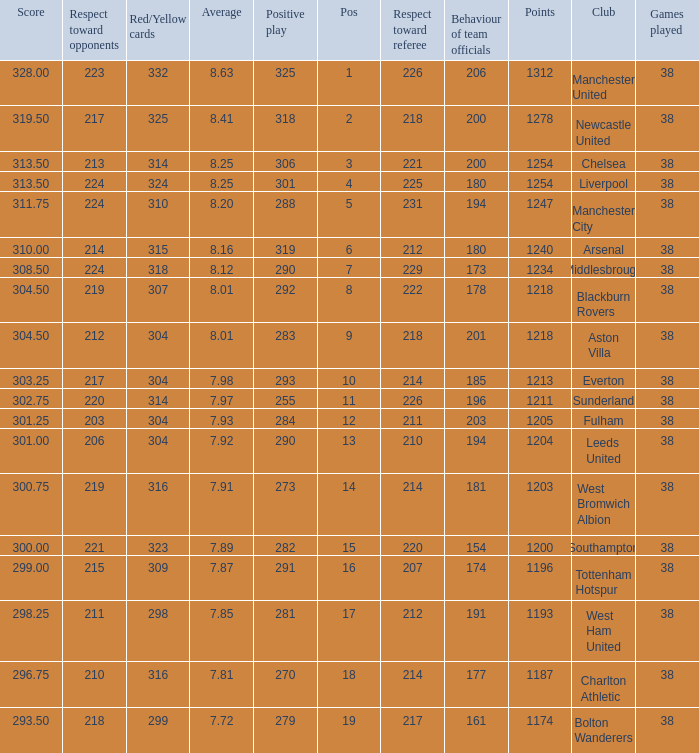Name the most red/yellow cards for positive play being 255 314.0. 